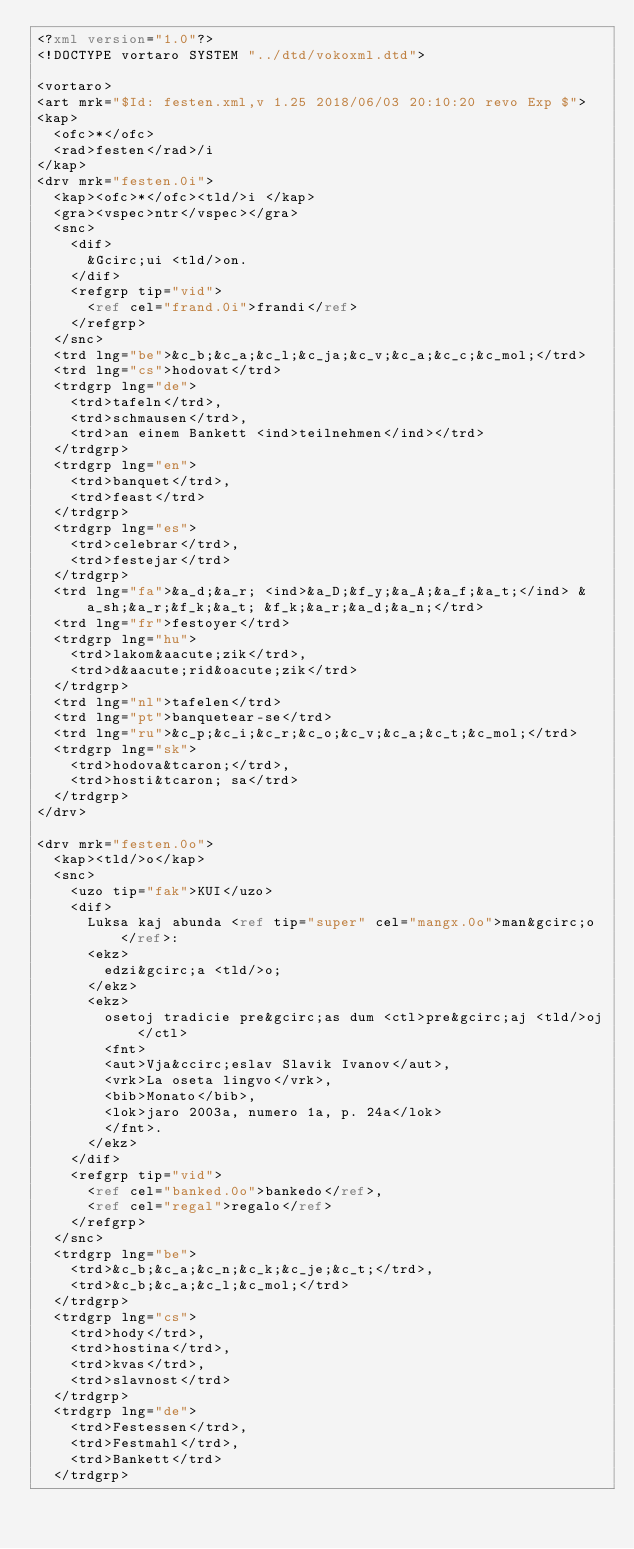Convert code to text. <code><loc_0><loc_0><loc_500><loc_500><_XML_><?xml version="1.0"?>
<!DOCTYPE vortaro SYSTEM "../dtd/vokoxml.dtd">

<vortaro>
<art mrk="$Id: festen.xml,v 1.25 2018/06/03 20:10:20 revo Exp $">
<kap>
  <ofc>*</ofc>
  <rad>festen</rad>/i
</kap>
<drv mrk="festen.0i">
  <kap><ofc>*</ofc><tld/>i </kap>
  <gra><vspec>ntr</vspec></gra>
  <snc>
    <dif>
      &Gcirc;ui <tld/>on.
    </dif>
    <refgrp tip="vid">
      <ref cel="frand.0i">frandi</ref>
    </refgrp>
  </snc>
  <trd lng="be">&c_b;&c_a;&c_l;&c_ja;&c_v;&c_a;&c_c;&c_mol;</trd>
  <trd lng="cs">hodovat</trd>
  <trdgrp lng="de">
    <trd>tafeln</trd>,
    <trd>schmausen</trd>,
    <trd>an einem Bankett <ind>teilnehmen</ind></trd>
  </trdgrp>
  <trdgrp lng="en">
    <trd>banquet</trd>,
    <trd>feast</trd>
  </trdgrp>
  <trdgrp lng="es">
    <trd>celebrar</trd>,
    <trd>festejar</trd>
  </trdgrp>
  <trd lng="fa">&a_d;&a_r; <ind>&a_D;&f_y;&a_A;&a_f;&a_t;</ind> &a_sh;&a_r;&f_k;&a_t; &f_k;&a_r;&a_d;&a_n;</trd>
  <trd lng="fr">festoyer</trd>
  <trdgrp lng="hu">
    <trd>lakom&aacute;zik</trd>,
    <trd>d&aacute;rid&oacute;zik</trd>
  </trdgrp>
  <trd lng="nl">tafelen</trd>
  <trd lng="pt">banquetear-se</trd>
  <trd lng="ru">&c_p;&c_i;&c_r;&c_o;&c_v;&c_a;&c_t;&c_mol;</trd>
  <trdgrp lng="sk">
    <trd>hodova&tcaron;</trd>,
    <trd>hosti&tcaron; sa</trd>
  </trdgrp>
</drv>

<drv mrk="festen.0o">
  <kap><tld/>o</kap>
  <snc>
    <uzo tip="fak">KUI</uzo>
    <dif>
      Luksa kaj abunda <ref tip="super" cel="mangx.0o">man&gcirc;o</ref>:
      <ekz>
        edzi&gcirc;a <tld/>o;
      </ekz>
      <ekz>
        osetoj tradicie pre&gcirc;as dum <ctl>pre&gcirc;aj <tld/>oj</ctl>
        <fnt>
        <aut>Vja&ccirc;eslav Slavik Ivanov</aut>,
        <vrk>La oseta lingvo</vrk>,
        <bib>Monato</bib>,
        <lok>jaro 2003a, numero 1a, p. 24a</lok>
        </fnt>.
      </ekz>
    </dif>
    <refgrp tip="vid">
      <ref cel="banked.0o">bankedo</ref>,
      <ref cel="regal">regalo</ref>
    </refgrp>
  </snc>
  <trdgrp lng="be">
    <trd>&c_b;&c_a;&c_n;&c_k;&c_je;&c_t;</trd>,
    <trd>&c_b;&c_a;&c_l;&c_mol;</trd>
  </trdgrp>
  <trdgrp lng="cs">
    <trd>hody</trd>,
    <trd>hostina</trd>,
    <trd>kvas</trd>,
    <trd>slavnost</trd>
  </trdgrp>
  <trdgrp lng="de">
    <trd>Festessen</trd>,
    <trd>Festmahl</trd>,
    <trd>Bankett</trd>
  </trdgrp></code> 